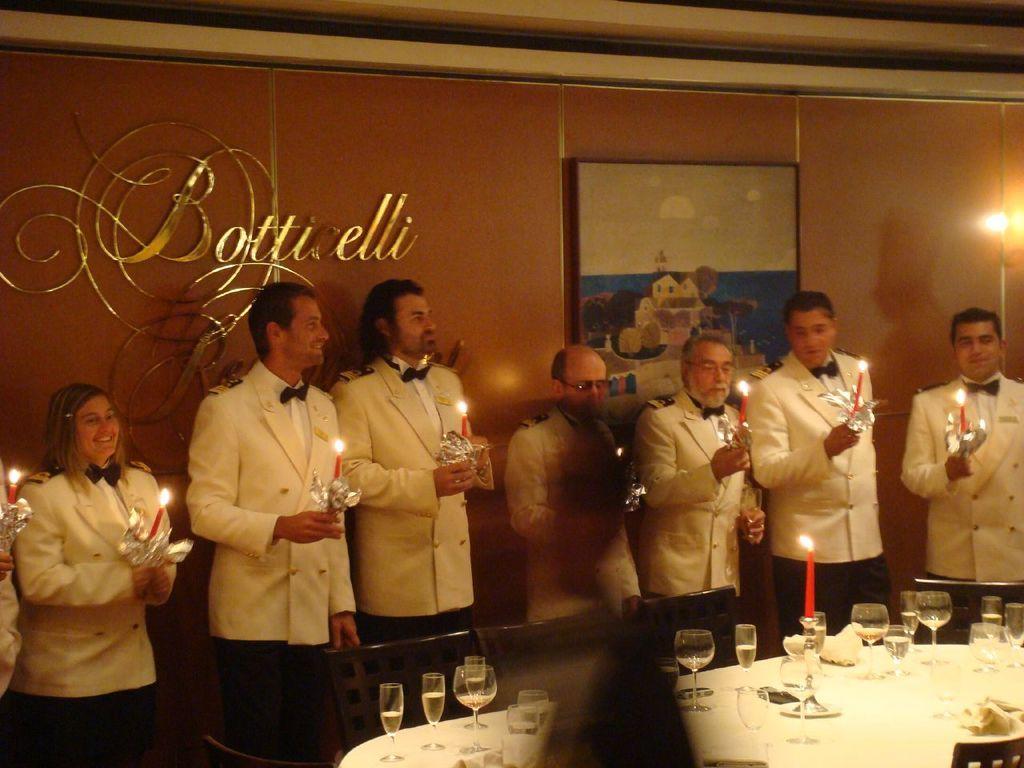Can you describe this image briefly? In this image few people are standing holding candle. they all are wearing white suit. In front of them on a table there are glasses. There are few chairs around the table. In the background there is a painting on the wall. 